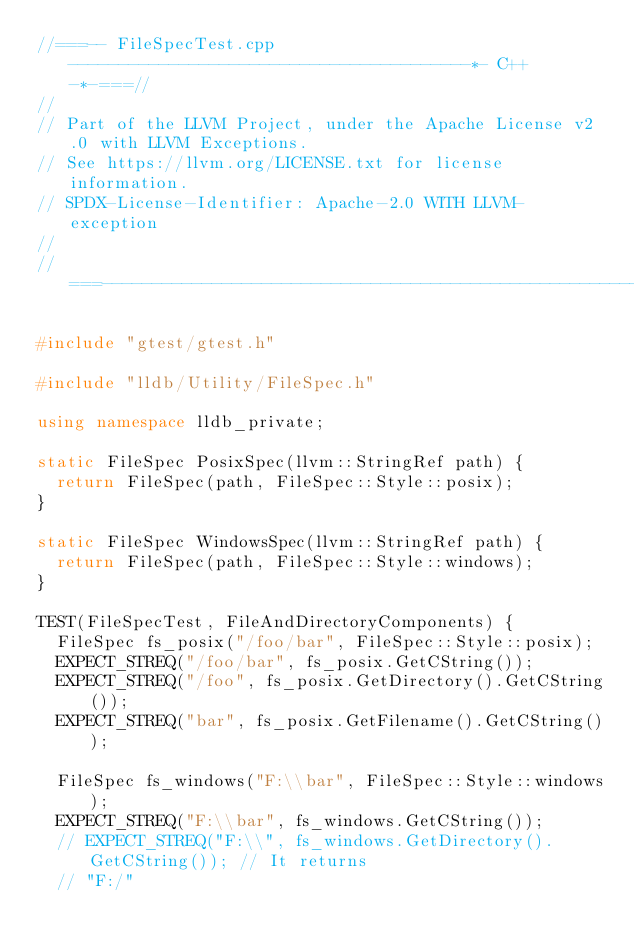<code> <loc_0><loc_0><loc_500><loc_500><_C++_>//===-- FileSpecTest.cpp ----------------------------------------*- C++ -*-===//
//
// Part of the LLVM Project, under the Apache License v2.0 with LLVM Exceptions.
// See https://llvm.org/LICENSE.txt for license information.
// SPDX-License-Identifier: Apache-2.0 WITH LLVM-exception
//
//===----------------------------------------------------------------------===//

#include "gtest/gtest.h"

#include "lldb/Utility/FileSpec.h"

using namespace lldb_private;

static FileSpec PosixSpec(llvm::StringRef path) {
  return FileSpec(path, FileSpec::Style::posix);
}

static FileSpec WindowsSpec(llvm::StringRef path) {
  return FileSpec(path, FileSpec::Style::windows);
}

TEST(FileSpecTest, FileAndDirectoryComponents) {
  FileSpec fs_posix("/foo/bar", FileSpec::Style::posix);
  EXPECT_STREQ("/foo/bar", fs_posix.GetCString());
  EXPECT_STREQ("/foo", fs_posix.GetDirectory().GetCString());
  EXPECT_STREQ("bar", fs_posix.GetFilename().GetCString());

  FileSpec fs_windows("F:\\bar", FileSpec::Style::windows);
  EXPECT_STREQ("F:\\bar", fs_windows.GetCString());
  // EXPECT_STREQ("F:\\", fs_windows.GetDirectory().GetCString()); // It returns
  // "F:/"</code> 